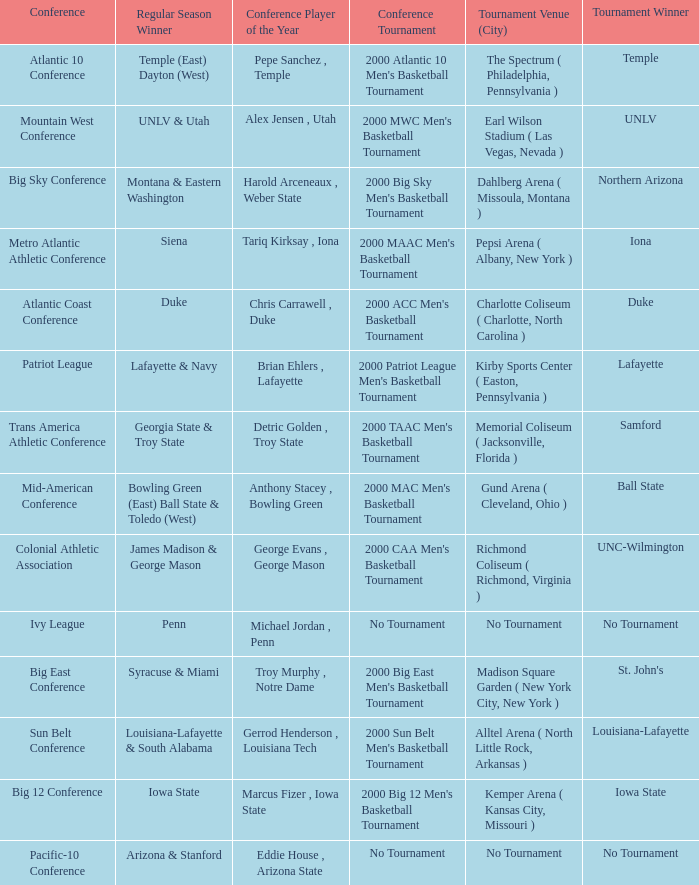What is the venue and city where the 2000 MWC Men's Basketball Tournament? Earl Wilson Stadium ( Las Vegas, Nevada ). 